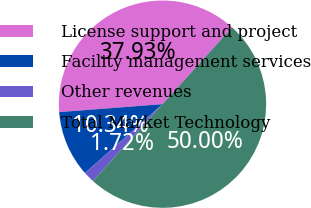Convert chart to OTSL. <chart><loc_0><loc_0><loc_500><loc_500><pie_chart><fcel>License support and project<fcel>Facility management services<fcel>Other revenues<fcel>Total Market Technology<nl><fcel>37.93%<fcel>10.34%<fcel>1.72%<fcel>50.0%<nl></chart> 